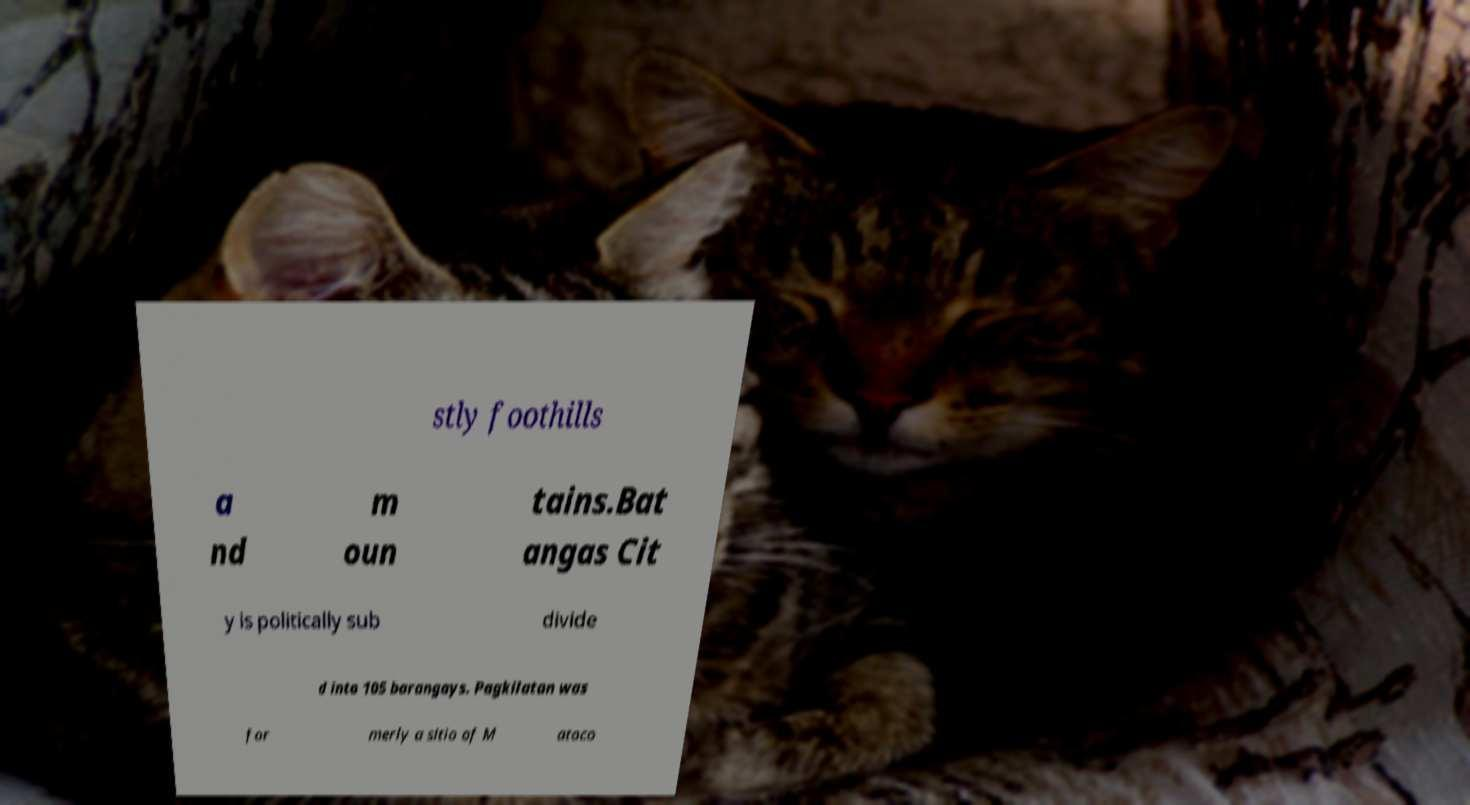Could you extract and type out the text from this image? stly foothills a nd m oun tains.Bat angas Cit y is politically sub divide d into 105 barangays. Pagkilatan was for merly a sitio of M atoco 